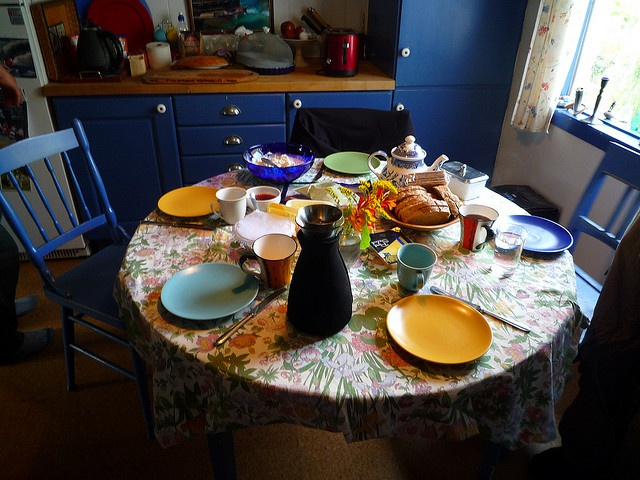Describe the objects in this image and their specific colors. I can see dining table in darkgreen, black, lightgray, darkgray, and gray tones, chair in darkgreen, black, gray, navy, and blue tones, chair in darkgreen, gray, navy, lightblue, and black tones, bottle in darkgreen, black, gray, white, and maroon tones, and chair in darkgreen, black, navy, gray, and darkblue tones in this image. 